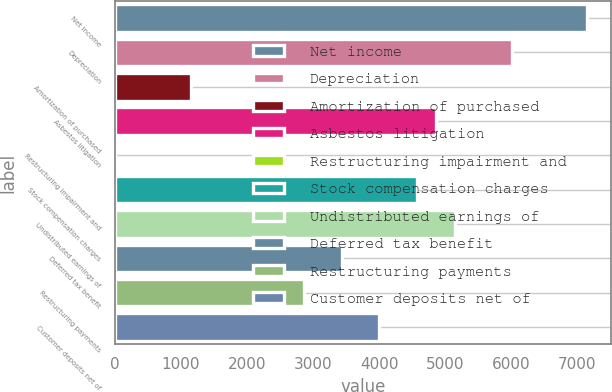Convert chart to OTSL. <chart><loc_0><loc_0><loc_500><loc_500><bar_chart><fcel>Net income<fcel>Depreciation<fcel>Amortization of purchased<fcel>Asbestos litigation<fcel>Restructuring impairment and<fcel>Stock compensation charges<fcel>Undistributed earnings of<fcel>Deferred tax benefit<fcel>Restructuring payments<fcel>Customer deposits net of<nl><fcel>7149<fcel>6005.8<fcel>1147.2<fcel>4862.6<fcel>4<fcel>4576.8<fcel>5148.4<fcel>3433.6<fcel>2862<fcel>4005.2<nl></chart> 